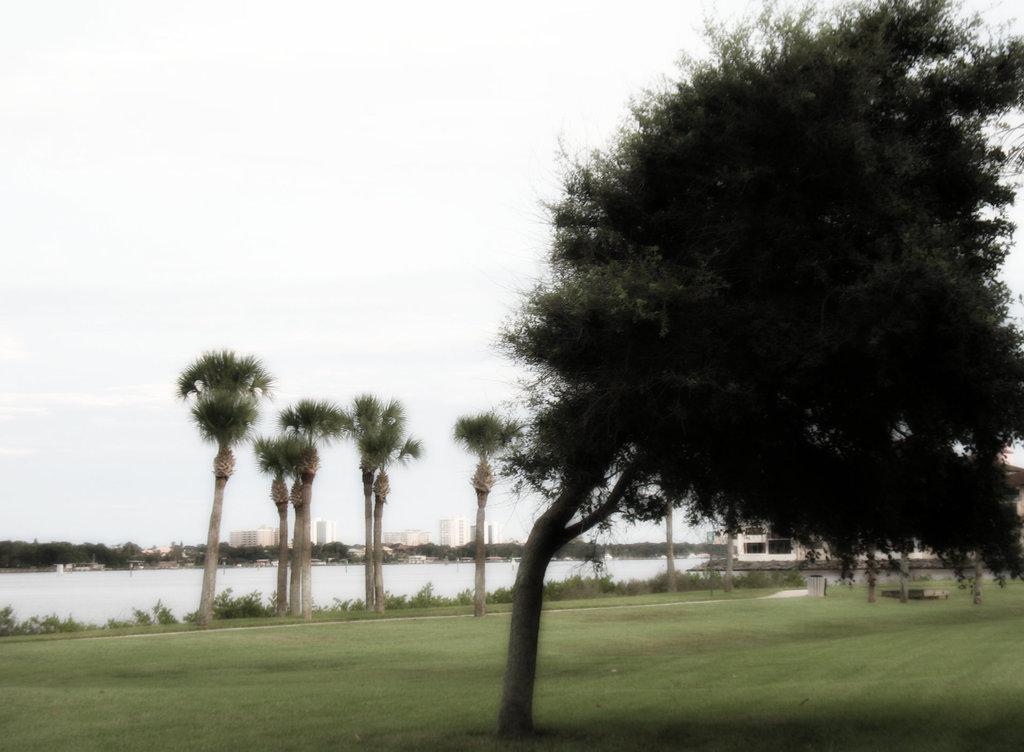What type of vegetation can be seen in the image? There are trees and grass in the image. What is visible on the ground in the image? The ground is visible in the image. What type of structure is present in the image? There is a building in the image. What can be seen in the background of the image? In the background, there is water, more trees, more buildings, and the sky visible. What color is the dress worn by the person in the tub in the image? There is no person in a tub present in the image. 